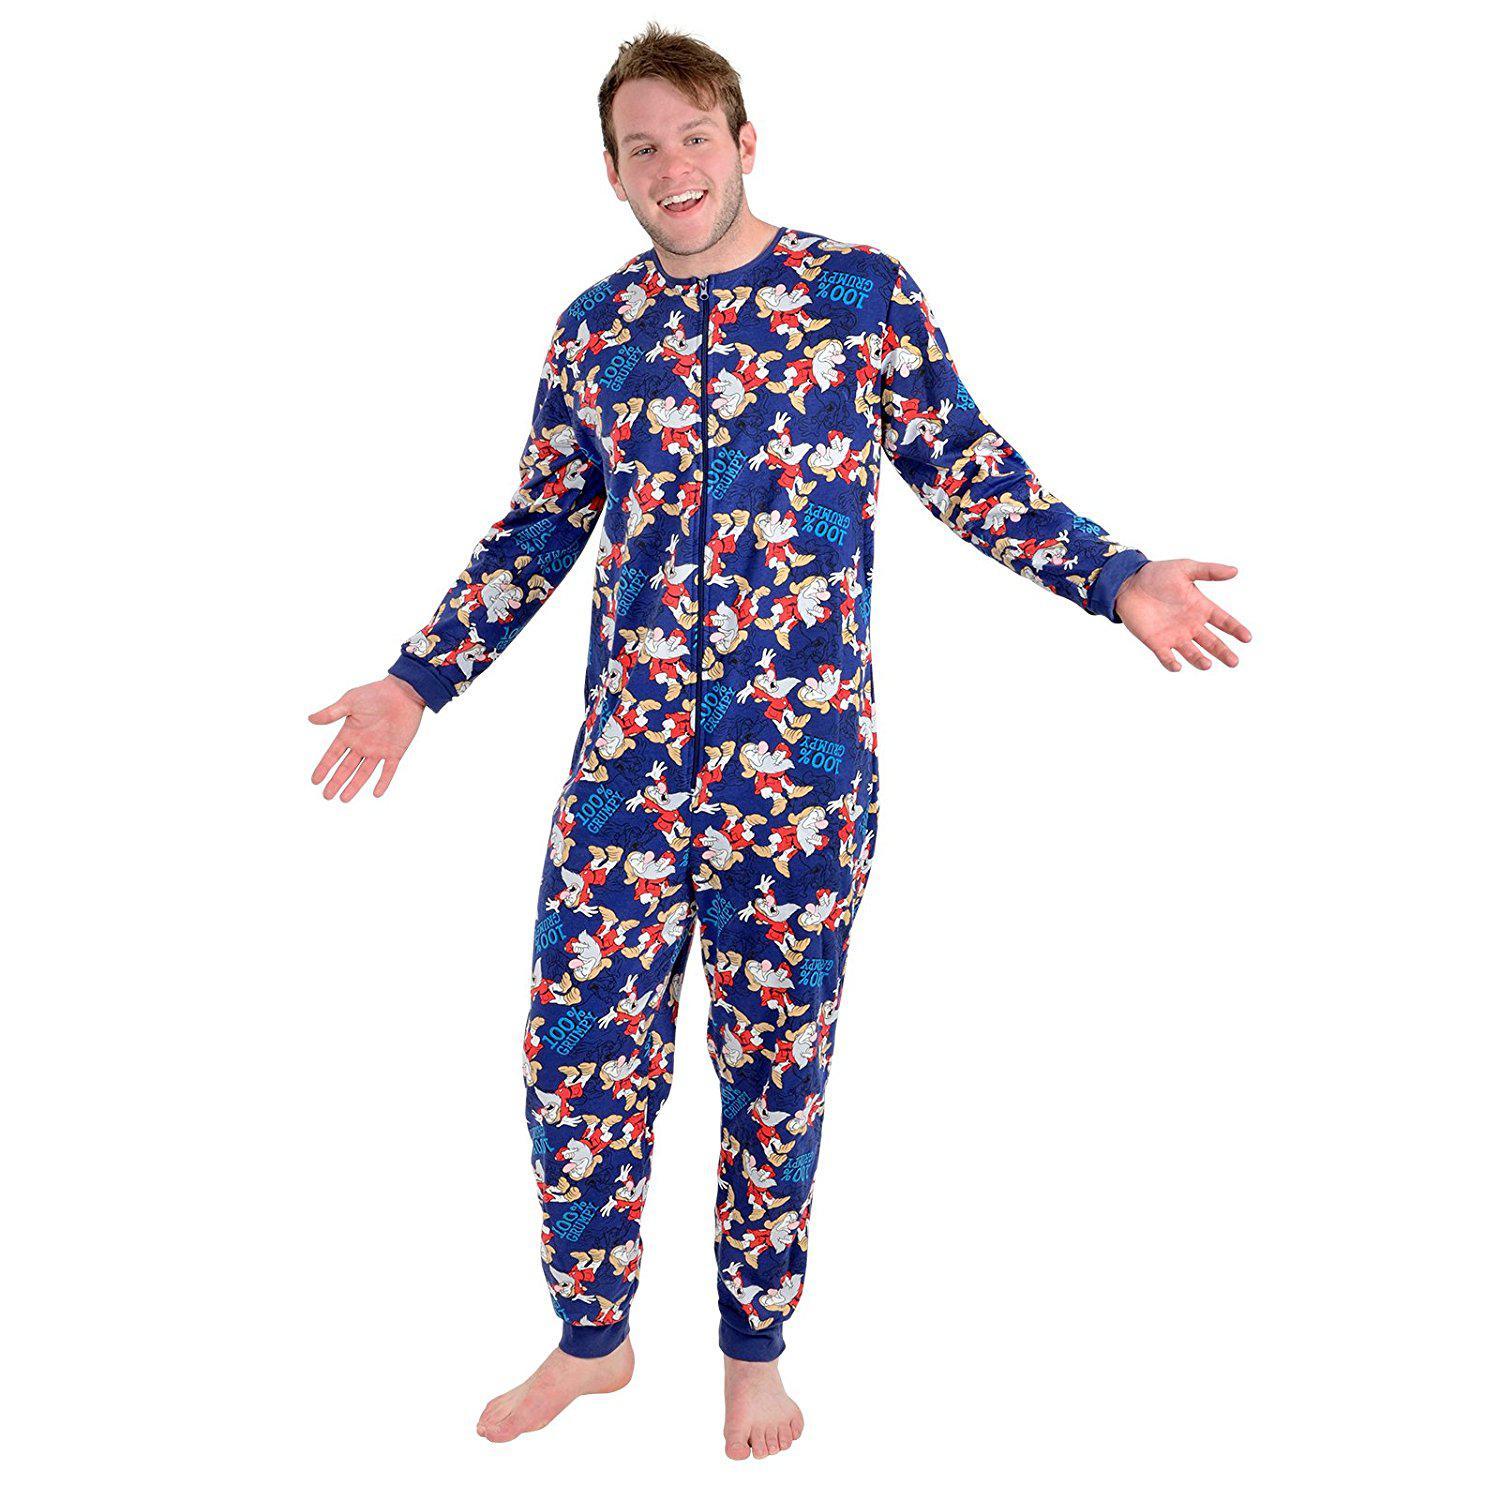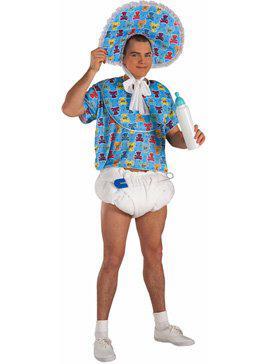The first image is the image on the left, the second image is the image on the right. Given the left and right images, does the statement "Two women are wearing footed pajamas, one of them with the attached hood pulled over her head." hold true? Answer yes or no. No. The first image is the image on the left, the second image is the image on the right. Given the left and right images, does the statement "Both images must be females." hold true? Answer yes or no. No. 